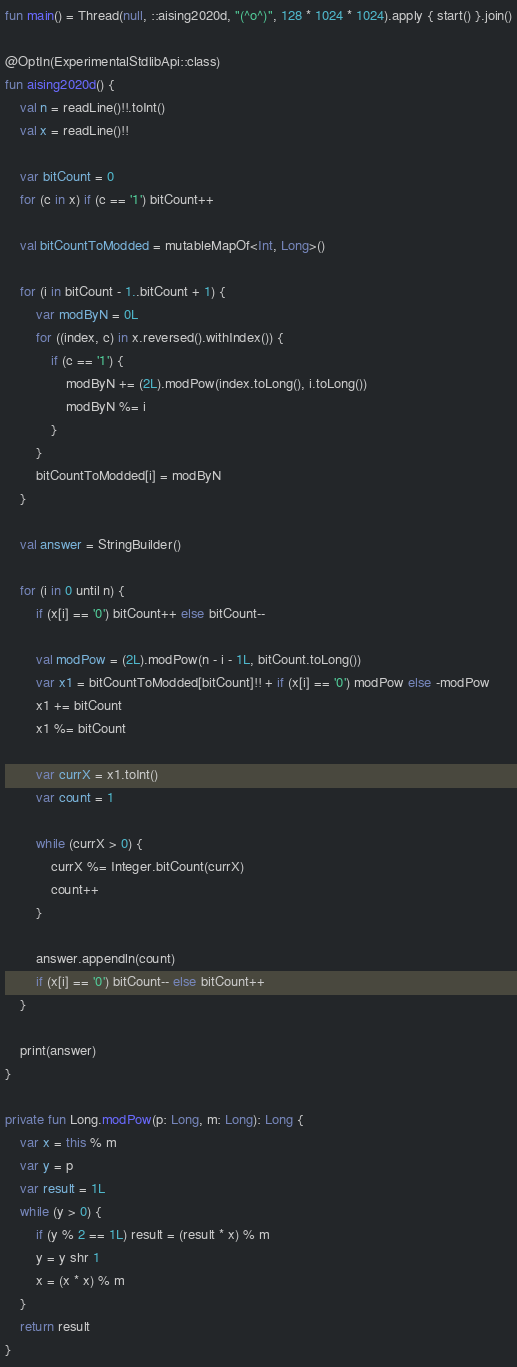<code> <loc_0><loc_0><loc_500><loc_500><_Kotlin_>fun main() = Thread(null, ::aising2020d, "(^o^)", 128 * 1024 * 1024).apply { start() }.join()

@OptIn(ExperimentalStdlibApi::class)
fun aising2020d() {
    val n = readLine()!!.toInt()
    val x = readLine()!!

    var bitCount = 0
    for (c in x) if (c == '1') bitCount++

    val bitCountToModded = mutableMapOf<Int, Long>()

    for (i in bitCount - 1..bitCount + 1) {
        var modByN = 0L
        for ((index, c) in x.reversed().withIndex()) {
            if (c == '1') {
                modByN += (2L).modPow(index.toLong(), i.toLong())
                modByN %= i
            }
        }
        bitCountToModded[i] = modByN
    }

    val answer = StringBuilder()

    for (i in 0 until n) {
        if (x[i] == '0') bitCount++ else bitCount--

        val modPow = (2L).modPow(n - i - 1L, bitCount.toLong())
        var x1 = bitCountToModded[bitCount]!! + if (x[i] == '0') modPow else -modPow
        x1 += bitCount
        x1 %= bitCount

        var currX = x1.toInt()
        var count = 1

        while (currX > 0) {
            currX %= Integer.bitCount(currX)
            count++
        }

        answer.appendln(count)
        if (x[i] == '0') bitCount-- else bitCount++
    }

    print(answer)
}

private fun Long.modPow(p: Long, m: Long): Long {
    var x = this % m
    var y = p
    var result = 1L
    while (y > 0) {
        if (y % 2 == 1L) result = (result * x) % m
        y = y shr 1
        x = (x * x) % m
    }
    return result
}
</code> 